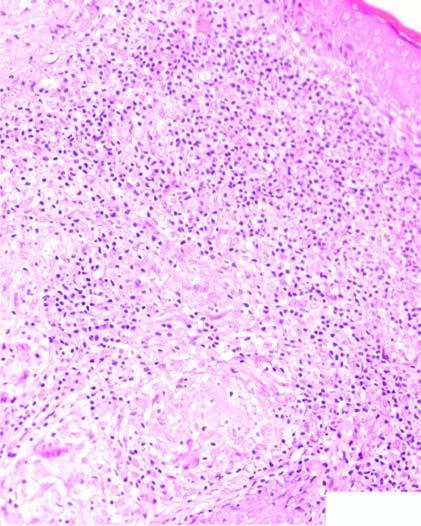what contains caseating epithelioid cell granulomas having giant cells and lymphocytes?
Answer the question using a single word or phrase. Dermis 